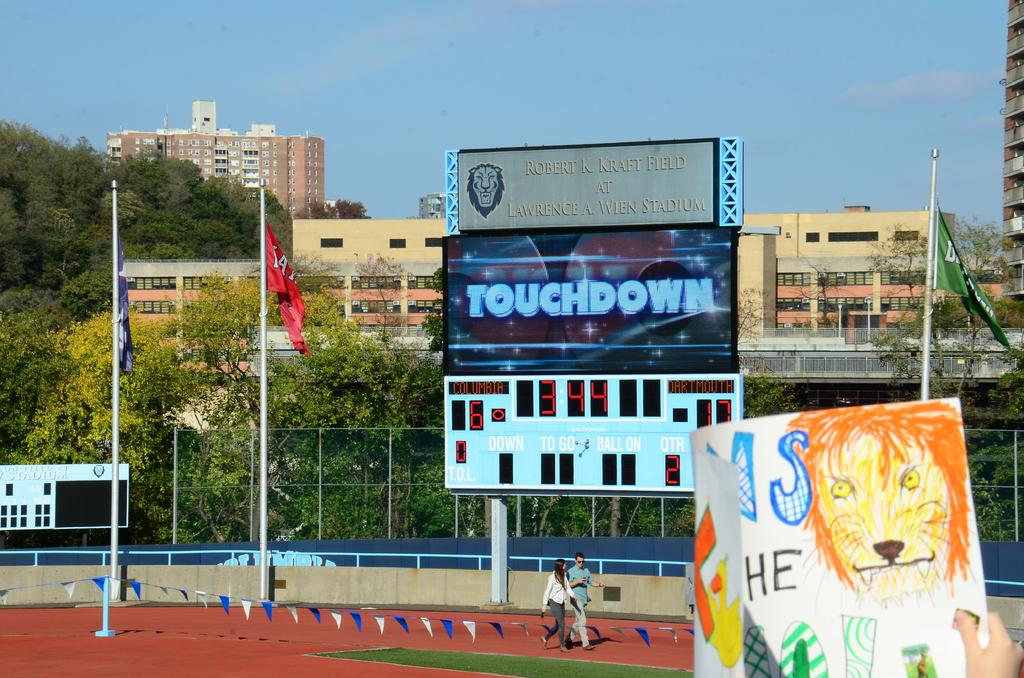<image>
Relay a brief, clear account of the picture shown. Sports stadium that says Touchdown on the screen. 